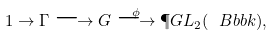<formula> <loc_0><loc_0><loc_500><loc_500>1 \to \Gamma \longrightarrow G \stackrel { \phi } \longrightarrow \P G L _ { 2 } ( \ B b b k ) ,</formula> 